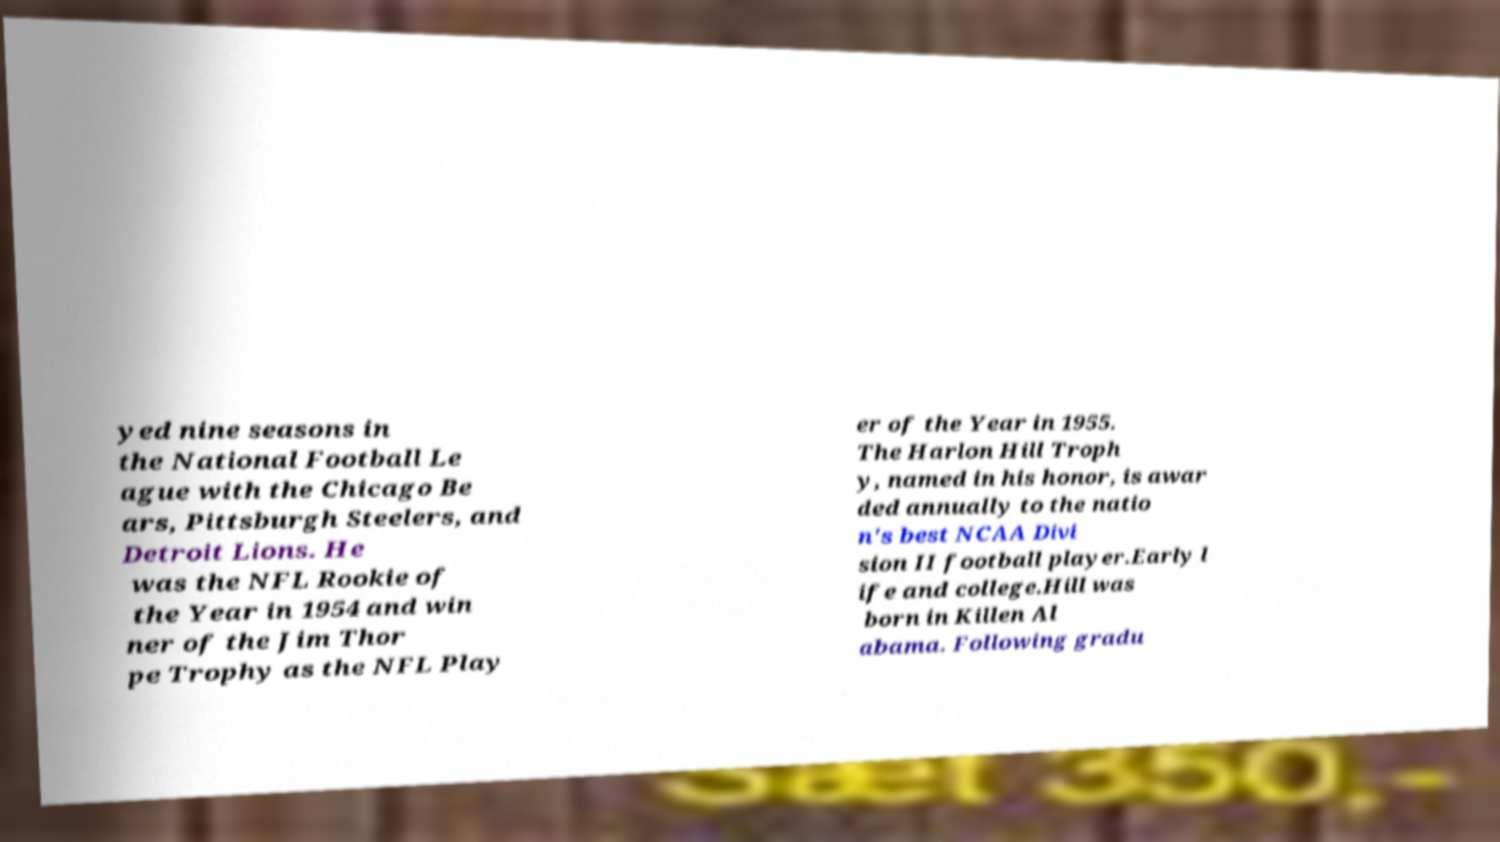For documentation purposes, I need the text within this image transcribed. Could you provide that? yed nine seasons in the National Football Le ague with the Chicago Be ars, Pittsburgh Steelers, and Detroit Lions. He was the NFL Rookie of the Year in 1954 and win ner of the Jim Thor pe Trophy as the NFL Play er of the Year in 1955. The Harlon Hill Troph y, named in his honor, is awar ded annually to the natio n's best NCAA Divi sion II football player.Early l ife and college.Hill was born in Killen Al abama. Following gradu 